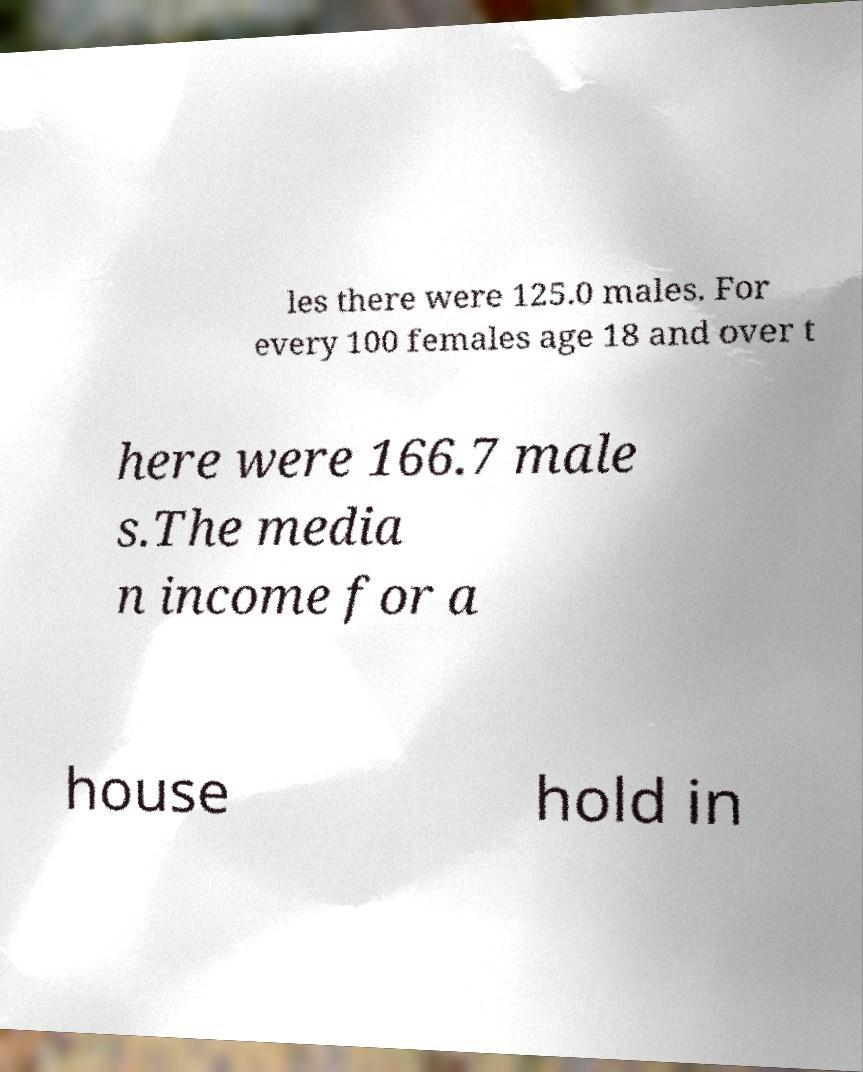I need the written content from this picture converted into text. Can you do that? les there were 125.0 males. For every 100 females age 18 and over t here were 166.7 male s.The media n income for a house hold in 